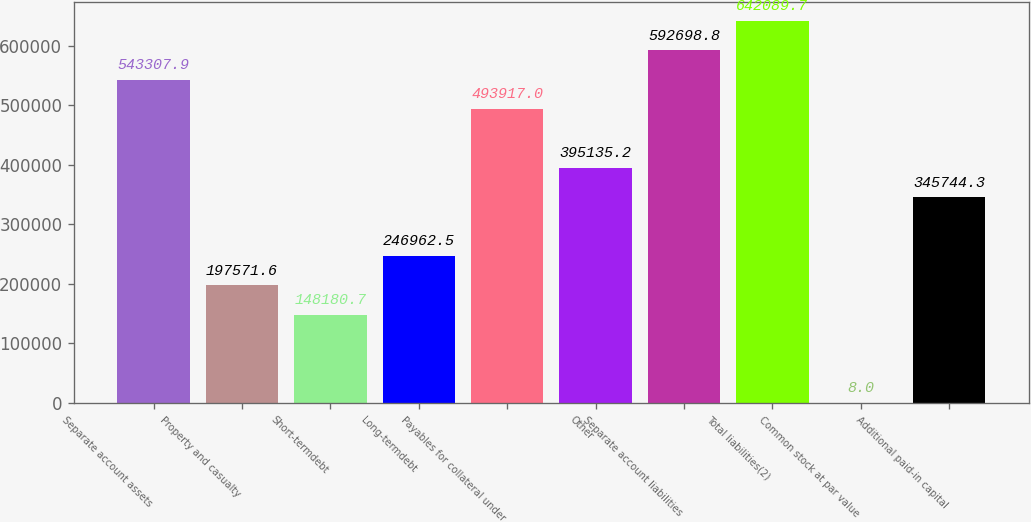Convert chart to OTSL. <chart><loc_0><loc_0><loc_500><loc_500><bar_chart><fcel>Separate account assets<fcel>Property and casualty<fcel>Short-termdebt<fcel>Long-termdebt<fcel>Payables for collateral under<fcel>Other<fcel>Separate account liabilities<fcel>Total liabilities(2)<fcel>Common stock at par value<fcel>Additional paid-in capital<nl><fcel>543308<fcel>197572<fcel>148181<fcel>246962<fcel>493917<fcel>395135<fcel>592699<fcel>642090<fcel>8<fcel>345744<nl></chart> 